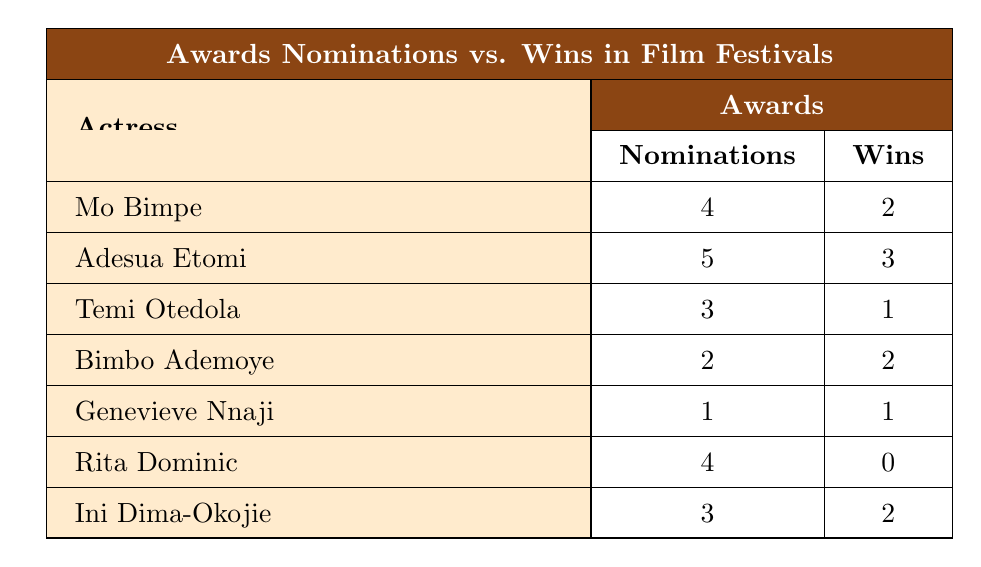What is the highest number of nominations received by an actress? The actress with the highest nominations is Adesua Etomi, with a total of 5 nominations at the Nigerian Entertainment Awards.
Answer: 5 Which actress has the most wins? Adesua Etomi has the most wins; she obtained 3 wins at the Nigerian Entertainment Awards.
Answer: Adesua Etomi Is it true that Rita Dominic won any awards? Rita Dominic received 4 nominations but did not win any awards, as indicated by her 0 wins.
Answer: No How many actresses have won at least one award? By counting the actresses with wins greater than 0, we find that 5 actresses won at least one award (Mo Bimpe, Adesua Etomi, Bimbo Ademoye, Genevieve Nnaji, and Ini Dima-Okojie).
Answer: 5 What is the total number of nominations for all actresses? Adding up all nominations: 4 (Mo Bimpe) + 5 (Adesua Etomi) + 3 (Temi Otedola) + 2 (Bimbo Ademoye) + 1 (Genevieve Nnaji) + 4 (Rita Dominic) + 3 (Ini Dima-Okojie) gives a total of 22 nominations.
Answer: 22 Which actress has a winning rate (wins/nominations) greater than 50%? To find the winning rate for each actress: Mo Bimpe (0.5), Adesua Etomi (0.6), Temi Otedola (0.33), Bimbo Ademoye (1.0), Genevieve Nnaji (1.0), Rita Dominic (0.0), Ini Dima-Okojie (0.67); Bimbo Ademoye and Genevieve Nnaji both have a winning rate of 100%, and Adesua Etomi and Ini Dima-Okojie have rates greater than 50%.
Answer: 4 actresses What percentage of Mo Bimpe's nominations resulted in wins? Mo Bimpe has 2 wins out of 4 nominations. To find the percentage, (2/4) * 100 = 50%.
Answer: 50% Which film festival had the least nominations in this data? The International Film Festival Rotterdam has the least nominations, with only 1 nomination received by Genevieve Nnaji.
Answer: 1 How many total wins are recorded in this table? By adding the wins: 2 (Mo Bimpe) + 3 (Adesua Etomi) + 1 (Temi Otedola) + 2 (Bimbo Ademoye) + 1 (Genevieve Nnaji) + 0 (Rita Dominic) + 2 (Ini Dima-Okojie) gives a total of 11 wins.
Answer: 11 